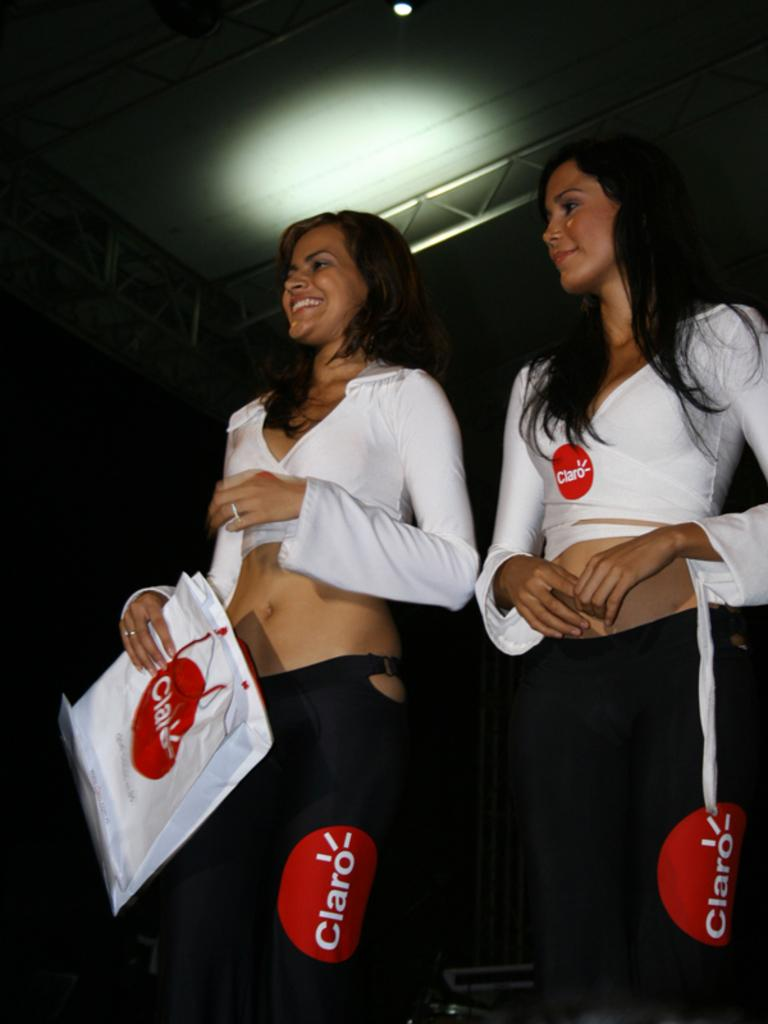<image>
Create a compact narrative representing the image presented. a claro logo on the side of a couple girls pants 